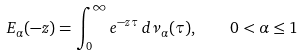<formula> <loc_0><loc_0><loc_500><loc_500>E _ { \alpha } ( - z ) = \int _ { 0 } ^ { \infty } e ^ { - z \tau } \, d \nu _ { \alpha } ( \tau ) , \quad 0 < \alpha \leq 1</formula> 